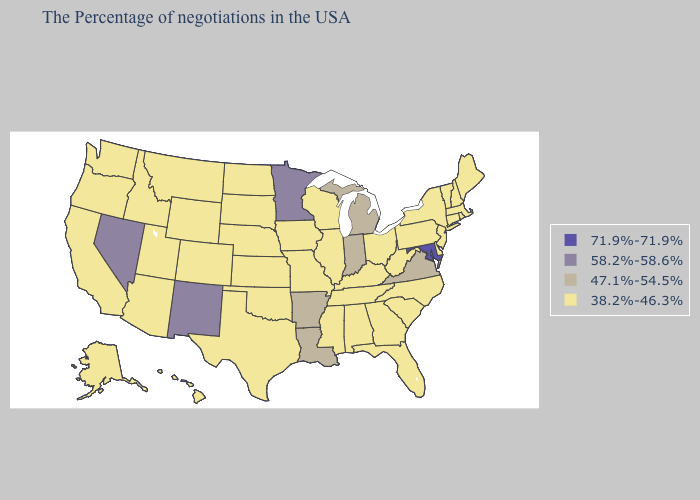Name the states that have a value in the range 58.2%-58.6%?
Give a very brief answer. Minnesota, New Mexico, Nevada. Does Maryland have the highest value in the USA?
Answer briefly. Yes. Name the states that have a value in the range 71.9%-71.9%?
Write a very short answer. Maryland. Name the states that have a value in the range 38.2%-46.3%?
Be succinct. Maine, Massachusetts, Rhode Island, New Hampshire, Vermont, Connecticut, New York, New Jersey, Delaware, Pennsylvania, North Carolina, South Carolina, West Virginia, Ohio, Florida, Georgia, Kentucky, Alabama, Tennessee, Wisconsin, Illinois, Mississippi, Missouri, Iowa, Kansas, Nebraska, Oklahoma, Texas, South Dakota, North Dakota, Wyoming, Colorado, Utah, Montana, Arizona, Idaho, California, Washington, Oregon, Alaska, Hawaii. Is the legend a continuous bar?
Write a very short answer. No. What is the value of Massachusetts?
Keep it brief. 38.2%-46.3%. Which states hav the highest value in the MidWest?
Keep it brief. Minnesota. Name the states that have a value in the range 47.1%-54.5%?
Answer briefly. Virginia, Michigan, Indiana, Louisiana, Arkansas. How many symbols are there in the legend?
Short answer required. 4. Name the states that have a value in the range 38.2%-46.3%?
Keep it brief. Maine, Massachusetts, Rhode Island, New Hampshire, Vermont, Connecticut, New York, New Jersey, Delaware, Pennsylvania, North Carolina, South Carolina, West Virginia, Ohio, Florida, Georgia, Kentucky, Alabama, Tennessee, Wisconsin, Illinois, Mississippi, Missouri, Iowa, Kansas, Nebraska, Oklahoma, Texas, South Dakota, North Dakota, Wyoming, Colorado, Utah, Montana, Arizona, Idaho, California, Washington, Oregon, Alaska, Hawaii. Which states hav the highest value in the South?
Be succinct. Maryland. Is the legend a continuous bar?
Answer briefly. No. Does South Dakota have the lowest value in the MidWest?
Concise answer only. Yes. What is the lowest value in the South?
Give a very brief answer. 38.2%-46.3%. 